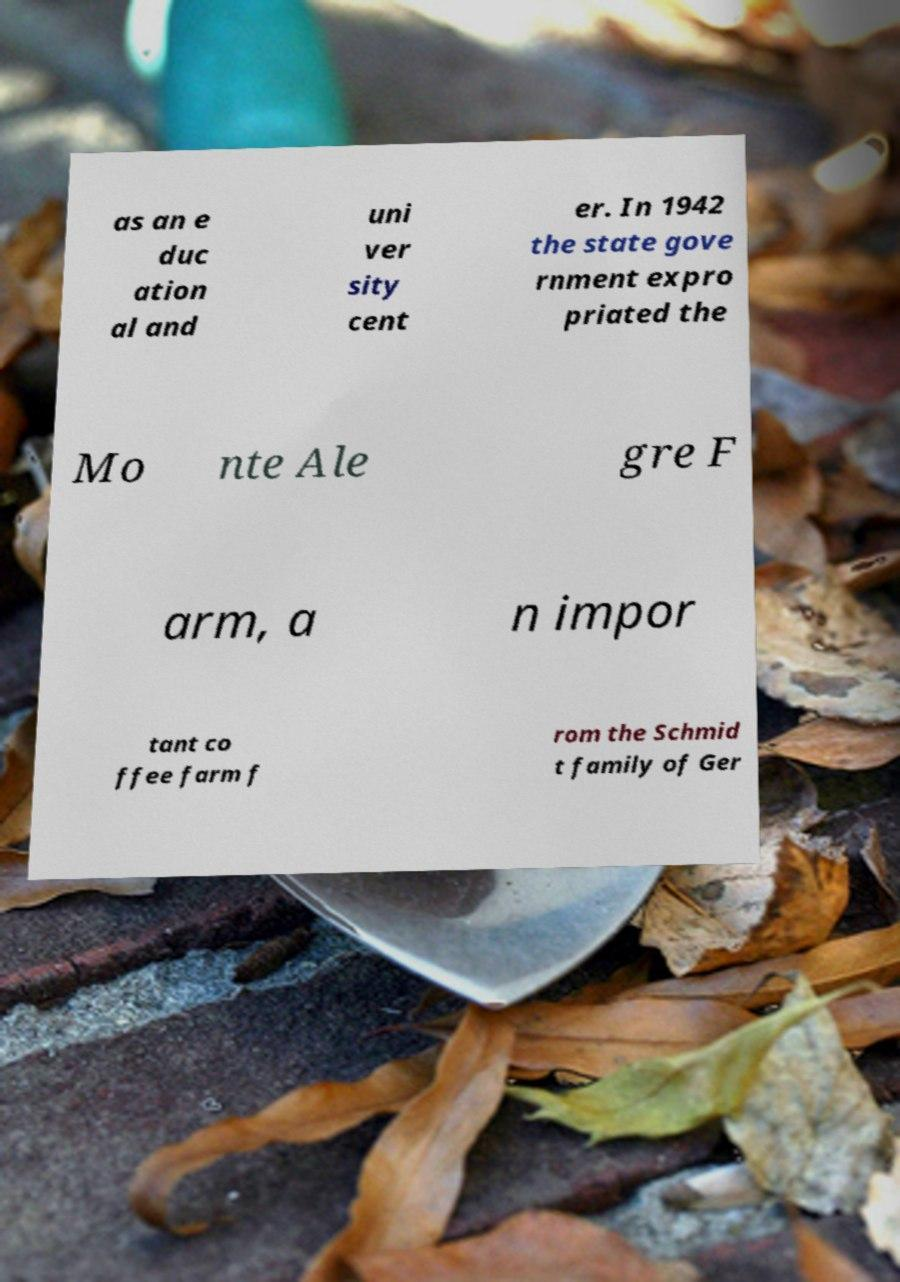Could you assist in decoding the text presented in this image and type it out clearly? as an e duc ation al and uni ver sity cent er. In 1942 the state gove rnment expro priated the Mo nte Ale gre F arm, a n impor tant co ffee farm f rom the Schmid t family of Ger 